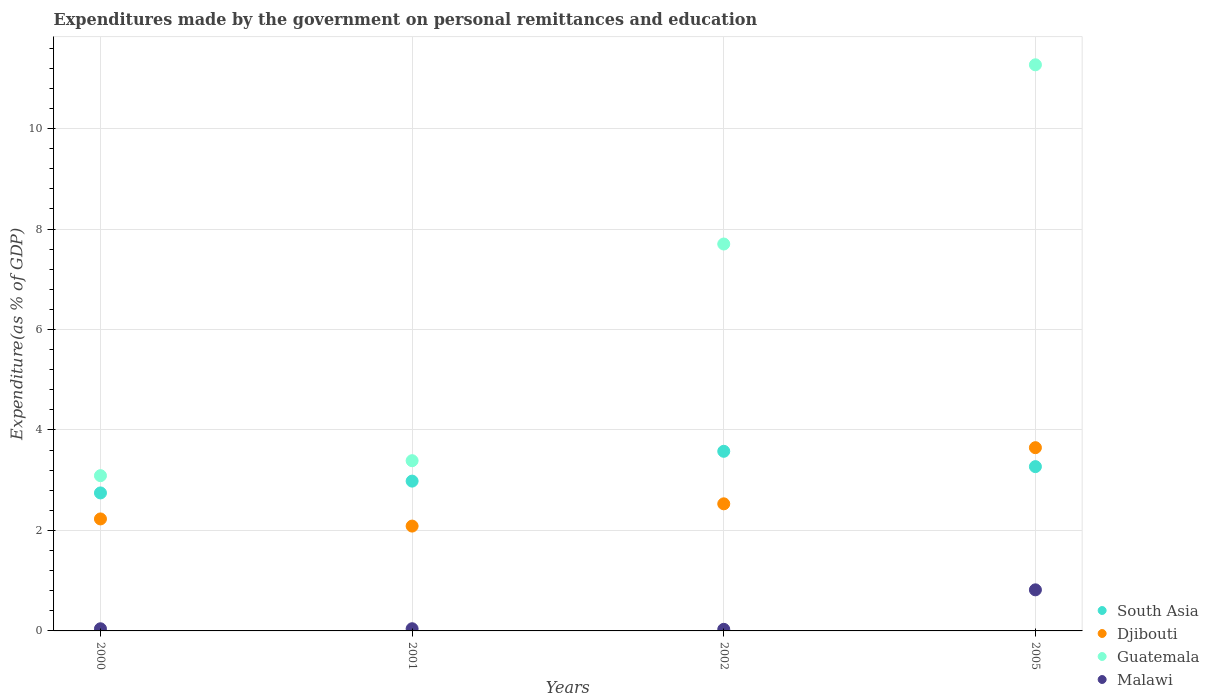Is the number of dotlines equal to the number of legend labels?
Your answer should be very brief. Yes. What is the expenditures made by the government on personal remittances and education in South Asia in 2000?
Your answer should be compact. 2.75. Across all years, what is the maximum expenditures made by the government on personal remittances and education in Malawi?
Keep it short and to the point. 0.82. Across all years, what is the minimum expenditures made by the government on personal remittances and education in Djibouti?
Your response must be concise. 2.09. In which year was the expenditures made by the government on personal remittances and education in South Asia maximum?
Your answer should be very brief. 2002. What is the total expenditures made by the government on personal remittances and education in Guatemala in the graph?
Give a very brief answer. 25.45. What is the difference between the expenditures made by the government on personal remittances and education in Djibouti in 2001 and that in 2005?
Offer a very short reply. -1.56. What is the difference between the expenditures made by the government on personal remittances and education in Guatemala in 2000 and the expenditures made by the government on personal remittances and education in Malawi in 2005?
Your answer should be compact. 2.27. What is the average expenditures made by the government on personal remittances and education in Guatemala per year?
Ensure brevity in your answer.  6.36. In the year 2001, what is the difference between the expenditures made by the government on personal remittances and education in South Asia and expenditures made by the government on personal remittances and education in Malawi?
Your answer should be very brief. 2.94. In how many years, is the expenditures made by the government on personal remittances and education in Guatemala greater than 3.2 %?
Keep it short and to the point. 3. What is the ratio of the expenditures made by the government on personal remittances and education in South Asia in 2000 to that in 2001?
Make the answer very short. 0.92. What is the difference between the highest and the second highest expenditures made by the government on personal remittances and education in Guatemala?
Offer a terse response. 3.57. What is the difference between the highest and the lowest expenditures made by the government on personal remittances and education in South Asia?
Your answer should be compact. 0.83. In how many years, is the expenditures made by the government on personal remittances and education in South Asia greater than the average expenditures made by the government on personal remittances and education in South Asia taken over all years?
Provide a short and direct response. 2. Is it the case that in every year, the sum of the expenditures made by the government on personal remittances and education in Djibouti and expenditures made by the government on personal remittances and education in Malawi  is greater than the sum of expenditures made by the government on personal remittances and education in Guatemala and expenditures made by the government on personal remittances and education in South Asia?
Provide a short and direct response. Yes. Is it the case that in every year, the sum of the expenditures made by the government on personal remittances and education in Djibouti and expenditures made by the government on personal remittances and education in Guatemala  is greater than the expenditures made by the government on personal remittances and education in South Asia?
Provide a succinct answer. Yes. How many years are there in the graph?
Keep it short and to the point. 4. Where does the legend appear in the graph?
Your response must be concise. Bottom right. What is the title of the graph?
Give a very brief answer. Expenditures made by the government on personal remittances and education. Does "Georgia" appear as one of the legend labels in the graph?
Your answer should be compact. No. What is the label or title of the Y-axis?
Make the answer very short. Expenditure(as % of GDP). What is the Expenditure(as % of GDP) in South Asia in 2000?
Offer a terse response. 2.75. What is the Expenditure(as % of GDP) of Djibouti in 2000?
Your response must be concise. 2.23. What is the Expenditure(as % of GDP) in Guatemala in 2000?
Your answer should be compact. 3.09. What is the Expenditure(as % of GDP) of Malawi in 2000?
Provide a short and direct response. 0.04. What is the Expenditure(as % of GDP) in South Asia in 2001?
Offer a terse response. 2.98. What is the Expenditure(as % of GDP) in Djibouti in 2001?
Make the answer very short. 2.09. What is the Expenditure(as % of GDP) of Guatemala in 2001?
Offer a terse response. 3.39. What is the Expenditure(as % of GDP) in Malawi in 2001?
Offer a very short reply. 0.04. What is the Expenditure(as % of GDP) in South Asia in 2002?
Offer a terse response. 3.58. What is the Expenditure(as % of GDP) in Djibouti in 2002?
Ensure brevity in your answer.  2.53. What is the Expenditure(as % of GDP) in Guatemala in 2002?
Provide a succinct answer. 7.7. What is the Expenditure(as % of GDP) in Malawi in 2002?
Give a very brief answer. 0.03. What is the Expenditure(as % of GDP) of South Asia in 2005?
Provide a short and direct response. 3.27. What is the Expenditure(as % of GDP) in Djibouti in 2005?
Ensure brevity in your answer.  3.65. What is the Expenditure(as % of GDP) in Guatemala in 2005?
Provide a short and direct response. 11.27. What is the Expenditure(as % of GDP) in Malawi in 2005?
Provide a short and direct response. 0.82. Across all years, what is the maximum Expenditure(as % of GDP) in South Asia?
Ensure brevity in your answer.  3.58. Across all years, what is the maximum Expenditure(as % of GDP) in Djibouti?
Your answer should be compact. 3.65. Across all years, what is the maximum Expenditure(as % of GDP) in Guatemala?
Your answer should be very brief. 11.27. Across all years, what is the maximum Expenditure(as % of GDP) in Malawi?
Your response must be concise. 0.82. Across all years, what is the minimum Expenditure(as % of GDP) in South Asia?
Keep it short and to the point. 2.75. Across all years, what is the minimum Expenditure(as % of GDP) of Djibouti?
Offer a terse response. 2.09. Across all years, what is the minimum Expenditure(as % of GDP) of Guatemala?
Your answer should be very brief. 3.09. Across all years, what is the minimum Expenditure(as % of GDP) in Malawi?
Make the answer very short. 0.03. What is the total Expenditure(as % of GDP) in South Asia in the graph?
Give a very brief answer. 12.58. What is the total Expenditure(as % of GDP) of Djibouti in the graph?
Ensure brevity in your answer.  10.49. What is the total Expenditure(as % of GDP) in Guatemala in the graph?
Keep it short and to the point. 25.45. What is the total Expenditure(as % of GDP) in Malawi in the graph?
Your answer should be compact. 0.94. What is the difference between the Expenditure(as % of GDP) in South Asia in 2000 and that in 2001?
Ensure brevity in your answer.  -0.24. What is the difference between the Expenditure(as % of GDP) in Djibouti in 2000 and that in 2001?
Your answer should be very brief. 0.14. What is the difference between the Expenditure(as % of GDP) in Guatemala in 2000 and that in 2001?
Keep it short and to the point. -0.3. What is the difference between the Expenditure(as % of GDP) in Malawi in 2000 and that in 2001?
Ensure brevity in your answer.  -0. What is the difference between the Expenditure(as % of GDP) of South Asia in 2000 and that in 2002?
Give a very brief answer. -0.83. What is the difference between the Expenditure(as % of GDP) in Djibouti in 2000 and that in 2002?
Offer a terse response. -0.3. What is the difference between the Expenditure(as % of GDP) in Guatemala in 2000 and that in 2002?
Give a very brief answer. -4.61. What is the difference between the Expenditure(as % of GDP) of Malawi in 2000 and that in 2002?
Make the answer very short. 0.01. What is the difference between the Expenditure(as % of GDP) of South Asia in 2000 and that in 2005?
Offer a very short reply. -0.52. What is the difference between the Expenditure(as % of GDP) of Djibouti in 2000 and that in 2005?
Ensure brevity in your answer.  -1.42. What is the difference between the Expenditure(as % of GDP) of Guatemala in 2000 and that in 2005?
Provide a short and direct response. -8.18. What is the difference between the Expenditure(as % of GDP) in Malawi in 2000 and that in 2005?
Offer a very short reply. -0.78. What is the difference between the Expenditure(as % of GDP) of South Asia in 2001 and that in 2002?
Make the answer very short. -0.59. What is the difference between the Expenditure(as % of GDP) of Djibouti in 2001 and that in 2002?
Keep it short and to the point. -0.44. What is the difference between the Expenditure(as % of GDP) of Guatemala in 2001 and that in 2002?
Provide a short and direct response. -4.31. What is the difference between the Expenditure(as % of GDP) of Malawi in 2001 and that in 2002?
Your answer should be very brief. 0.01. What is the difference between the Expenditure(as % of GDP) in South Asia in 2001 and that in 2005?
Provide a short and direct response. -0.29. What is the difference between the Expenditure(as % of GDP) in Djibouti in 2001 and that in 2005?
Make the answer very short. -1.56. What is the difference between the Expenditure(as % of GDP) in Guatemala in 2001 and that in 2005?
Provide a succinct answer. -7.88. What is the difference between the Expenditure(as % of GDP) in Malawi in 2001 and that in 2005?
Ensure brevity in your answer.  -0.77. What is the difference between the Expenditure(as % of GDP) of South Asia in 2002 and that in 2005?
Your answer should be compact. 0.3. What is the difference between the Expenditure(as % of GDP) in Djibouti in 2002 and that in 2005?
Ensure brevity in your answer.  -1.12. What is the difference between the Expenditure(as % of GDP) of Guatemala in 2002 and that in 2005?
Offer a terse response. -3.57. What is the difference between the Expenditure(as % of GDP) in Malawi in 2002 and that in 2005?
Provide a short and direct response. -0.79. What is the difference between the Expenditure(as % of GDP) of South Asia in 2000 and the Expenditure(as % of GDP) of Djibouti in 2001?
Your answer should be compact. 0.66. What is the difference between the Expenditure(as % of GDP) of South Asia in 2000 and the Expenditure(as % of GDP) of Guatemala in 2001?
Give a very brief answer. -0.64. What is the difference between the Expenditure(as % of GDP) of South Asia in 2000 and the Expenditure(as % of GDP) of Malawi in 2001?
Give a very brief answer. 2.7. What is the difference between the Expenditure(as % of GDP) of Djibouti in 2000 and the Expenditure(as % of GDP) of Guatemala in 2001?
Provide a succinct answer. -1.16. What is the difference between the Expenditure(as % of GDP) of Djibouti in 2000 and the Expenditure(as % of GDP) of Malawi in 2001?
Give a very brief answer. 2.19. What is the difference between the Expenditure(as % of GDP) in Guatemala in 2000 and the Expenditure(as % of GDP) in Malawi in 2001?
Offer a terse response. 3.05. What is the difference between the Expenditure(as % of GDP) of South Asia in 2000 and the Expenditure(as % of GDP) of Djibouti in 2002?
Make the answer very short. 0.22. What is the difference between the Expenditure(as % of GDP) of South Asia in 2000 and the Expenditure(as % of GDP) of Guatemala in 2002?
Provide a succinct answer. -4.96. What is the difference between the Expenditure(as % of GDP) in South Asia in 2000 and the Expenditure(as % of GDP) in Malawi in 2002?
Make the answer very short. 2.72. What is the difference between the Expenditure(as % of GDP) in Djibouti in 2000 and the Expenditure(as % of GDP) in Guatemala in 2002?
Give a very brief answer. -5.47. What is the difference between the Expenditure(as % of GDP) of Djibouti in 2000 and the Expenditure(as % of GDP) of Malawi in 2002?
Offer a very short reply. 2.2. What is the difference between the Expenditure(as % of GDP) of Guatemala in 2000 and the Expenditure(as % of GDP) of Malawi in 2002?
Offer a terse response. 3.06. What is the difference between the Expenditure(as % of GDP) in South Asia in 2000 and the Expenditure(as % of GDP) in Djibouti in 2005?
Offer a very short reply. -0.9. What is the difference between the Expenditure(as % of GDP) of South Asia in 2000 and the Expenditure(as % of GDP) of Guatemala in 2005?
Your response must be concise. -8.52. What is the difference between the Expenditure(as % of GDP) of South Asia in 2000 and the Expenditure(as % of GDP) of Malawi in 2005?
Make the answer very short. 1.93. What is the difference between the Expenditure(as % of GDP) in Djibouti in 2000 and the Expenditure(as % of GDP) in Guatemala in 2005?
Offer a terse response. -9.04. What is the difference between the Expenditure(as % of GDP) in Djibouti in 2000 and the Expenditure(as % of GDP) in Malawi in 2005?
Give a very brief answer. 1.41. What is the difference between the Expenditure(as % of GDP) in Guatemala in 2000 and the Expenditure(as % of GDP) in Malawi in 2005?
Ensure brevity in your answer.  2.27. What is the difference between the Expenditure(as % of GDP) in South Asia in 2001 and the Expenditure(as % of GDP) in Djibouti in 2002?
Offer a very short reply. 0.45. What is the difference between the Expenditure(as % of GDP) in South Asia in 2001 and the Expenditure(as % of GDP) in Guatemala in 2002?
Keep it short and to the point. -4.72. What is the difference between the Expenditure(as % of GDP) in South Asia in 2001 and the Expenditure(as % of GDP) in Malawi in 2002?
Your response must be concise. 2.95. What is the difference between the Expenditure(as % of GDP) in Djibouti in 2001 and the Expenditure(as % of GDP) in Guatemala in 2002?
Ensure brevity in your answer.  -5.62. What is the difference between the Expenditure(as % of GDP) of Djibouti in 2001 and the Expenditure(as % of GDP) of Malawi in 2002?
Make the answer very short. 2.06. What is the difference between the Expenditure(as % of GDP) of Guatemala in 2001 and the Expenditure(as % of GDP) of Malawi in 2002?
Your answer should be very brief. 3.36. What is the difference between the Expenditure(as % of GDP) in South Asia in 2001 and the Expenditure(as % of GDP) in Djibouti in 2005?
Offer a terse response. -0.67. What is the difference between the Expenditure(as % of GDP) of South Asia in 2001 and the Expenditure(as % of GDP) of Guatemala in 2005?
Provide a short and direct response. -8.29. What is the difference between the Expenditure(as % of GDP) in South Asia in 2001 and the Expenditure(as % of GDP) in Malawi in 2005?
Provide a short and direct response. 2.16. What is the difference between the Expenditure(as % of GDP) in Djibouti in 2001 and the Expenditure(as % of GDP) in Guatemala in 2005?
Your answer should be compact. -9.18. What is the difference between the Expenditure(as % of GDP) of Djibouti in 2001 and the Expenditure(as % of GDP) of Malawi in 2005?
Provide a succinct answer. 1.27. What is the difference between the Expenditure(as % of GDP) in Guatemala in 2001 and the Expenditure(as % of GDP) in Malawi in 2005?
Provide a succinct answer. 2.57. What is the difference between the Expenditure(as % of GDP) of South Asia in 2002 and the Expenditure(as % of GDP) of Djibouti in 2005?
Offer a very short reply. -0.07. What is the difference between the Expenditure(as % of GDP) in South Asia in 2002 and the Expenditure(as % of GDP) in Guatemala in 2005?
Keep it short and to the point. -7.69. What is the difference between the Expenditure(as % of GDP) in South Asia in 2002 and the Expenditure(as % of GDP) in Malawi in 2005?
Your answer should be compact. 2.76. What is the difference between the Expenditure(as % of GDP) of Djibouti in 2002 and the Expenditure(as % of GDP) of Guatemala in 2005?
Your answer should be compact. -8.74. What is the difference between the Expenditure(as % of GDP) of Djibouti in 2002 and the Expenditure(as % of GDP) of Malawi in 2005?
Your response must be concise. 1.71. What is the difference between the Expenditure(as % of GDP) in Guatemala in 2002 and the Expenditure(as % of GDP) in Malawi in 2005?
Offer a very short reply. 6.88. What is the average Expenditure(as % of GDP) in South Asia per year?
Provide a succinct answer. 3.14. What is the average Expenditure(as % of GDP) in Djibouti per year?
Your answer should be very brief. 2.62. What is the average Expenditure(as % of GDP) in Guatemala per year?
Your answer should be compact. 6.36. What is the average Expenditure(as % of GDP) of Malawi per year?
Offer a terse response. 0.23. In the year 2000, what is the difference between the Expenditure(as % of GDP) in South Asia and Expenditure(as % of GDP) in Djibouti?
Your answer should be very brief. 0.52. In the year 2000, what is the difference between the Expenditure(as % of GDP) of South Asia and Expenditure(as % of GDP) of Guatemala?
Your answer should be compact. -0.34. In the year 2000, what is the difference between the Expenditure(as % of GDP) in South Asia and Expenditure(as % of GDP) in Malawi?
Your response must be concise. 2.7. In the year 2000, what is the difference between the Expenditure(as % of GDP) in Djibouti and Expenditure(as % of GDP) in Guatemala?
Your answer should be very brief. -0.86. In the year 2000, what is the difference between the Expenditure(as % of GDP) of Djibouti and Expenditure(as % of GDP) of Malawi?
Your answer should be very brief. 2.19. In the year 2000, what is the difference between the Expenditure(as % of GDP) of Guatemala and Expenditure(as % of GDP) of Malawi?
Your response must be concise. 3.05. In the year 2001, what is the difference between the Expenditure(as % of GDP) in South Asia and Expenditure(as % of GDP) in Djibouti?
Your answer should be compact. 0.9. In the year 2001, what is the difference between the Expenditure(as % of GDP) in South Asia and Expenditure(as % of GDP) in Guatemala?
Give a very brief answer. -0.41. In the year 2001, what is the difference between the Expenditure(as % of GDP) of South Asia and Expenditure(as % of GDP) of Malawi?
Your answer should be compact. 2.94. In the year 2001, what is the difference between the Expenditure(as % of GDP) of Djibouti and Expenditure(as % of GDP) of Guatemala?
Provide a short and direct response. -1.3. In the year 2001, what is the difference between the Expenditure(as % of GDP) in Djibouti and Expenditure(as % of GDP) in Malawi?
Provide a short and direct response. 2.04. In the year 2001, what is the difference between the Expenditure(as % of GDP) in Guatemala and Expenditure(as % of GDP) in Malawi?
Make the answer very short. 3.35. In the year 2002, what is the difference between the Expenditure(as % of GDP) of South Asia and Expenditure(as % of GDP) of Djibouti?
Offer a very short reply. 1.05. In the year 2002, what is the difference between the Expenditure(as % of GDP) in South Asia and Expenditure(as % of GDP) in Guatemala?
Keep it short and to the point. -4.13. In the year 2002, what is the difference between the Expenditure(as % of GDP) of South Asia and Expenditure(as % of GDP) of Malawi?
Offer a very short reply. 3.54. In the year 2002, what is the difference between the Expenditure(as % of GDP) of Djibouti and Expenditure(as % of GDP) of Guatemala?
Your answer should be very brief. -5.17. In the year 2002, what is the difference between the Expenditure(as % of GDP) in Djibouti and Expenditure(as % of GDP) in Malawi?
Your response must be concise. 2.5. In the year 2002, what is the difference between the Expenditure(as % of GDP) of Guatemala and Expenditure(as % of GDP) of Malawi?
Keep it short and to the point. 7.67. In the year 2005, what is the difference between the Expenditure(as % of GDP) of South Asia and Expenditure(as % of GDP) of Djibouti?
Give a very brief answer. -0.38. In the year 2005, what is the difference between the Expenditure(as % of GDP) of South Asia and Expenditure(as % of GDP) of Guatemala?
Offer a very short reply. -8. In the year 2005, what is the difference between the Expenditure(as % of GDP) in South Asia and Expenditure(as % of GDP) in Malawi?
Offer a very short reply. 2.45. In the year 2005, what is the difference between the Expenditure(as % of GDP) of Djibouti and Expenditure(as % of GDP) of Guatemala?
Offer a terse response. -7.62. In the year 2005, what is the difference between the Expenditure(as % of GDP) of Djibouti and Expenditure(as % of GDP) of Malawi?
Offer a terse response. 2.83. In the year 2005, what is the difference between the Expenditure(as % of GDP) of Guatemala and Expenditure(as % of GDP) of Malawi?
Provide a succinct answer. 10.45. What is the ratio of the Expenditure(as % of GDP) in South Asia in 2000 to that in 2001?
Keep it short and to the point. 0.92. What is the ratio of the Expenditure(as % of GDP) in Djibouti in 2000 to that in 2001?
Give a very brief answer. 1.07. What is the ratio of the Expenditure(as % of GDP) of Guatemala in 2000 to that in 2001?
Your answer should be very brief. 0.91. What is the ratio of the Expenditure(as % of GDP) of Malawi in 2000 to that in 2001?
Offer a terse response. 0.98. What is the ratio of the Expenditure(as % of GDP) in South Asia in 2000 to that in 2002?
Your answer should be very brief. 0.77. What is the ratio of the Expenditure(as % of GDP) in Djibouti in 2000 to that in 2002?
Your answer should be very brief. 0.88. What is the ratio of the Expenditure(as % of GDP) in Guatemala in 2000 to that in 2002?
Provide a short and direct response. 0.4. What is the ratio of the Expenditure(as % of GDP) of Malawi in 2000 to that in 2002?
Make the answer very short. 1.35. What is the ratio of the Expenditure(as % of GDP) in South Asia in 2000 to that in 2005?
Give a very brief answer. 0.84. What is the ratio of the Expenditure(as % of GDP) in Djibouti in 2000 to that in 2005?
Offer a very short reply. 0.61. What is the ratio of the Expenditure(as % of GDP) of Guatemala in 2000 to that in 2005?
Give a very brief answer. 0.27. What is the ratio of the Expenditure(as % of GDP) in Malawi in 2000 to that in 2005?
Provide a short and direct response. 0.05. What is the ratio of the Expenditure(as % of GDP) in South Asia in 2001 to that in 2002?
Ensure brevity in your answer.  0.83. What is the ratio of the Expenditure(as % of GDP) in Djibouti in 2001 to that in 2002?
Your answer should be compact. 0.82. What is the ratio of the Expenditure(as % of GDP) in Guatemala in 2001 to that in 2002?
Keep it short and to the point. 0.44. What is the ratio of the Expenditure(as % of GDP) in Malawi in 2001 to that in 2002?
Provide a succinct answer. 1.37. What is the ratio of the Expenditure(as % of GDP) of South Asia in 2001 to that in 2005?
Offer a terse response. 0.91. What is the ratio of the Expenditure(as % of GDP) of Djibouti in 2001 to that in 2005?
Give a very brief answer. 0.57. What is the ratio of the Expenditure(as % of GDP) of Guatemala in 2001 to that in 2005?
Keep it short and to the point. 0.3. What is the ratio of the Expenditure(as % of GDP) in Malawi in 2001 to that in 2005?
Provide a short and direct response. 0.05. What is the ratio of the Expenditure(as % of GDP) in South Asia in 2002 to that in 2005?
Your answer should be very brief. 1.09. What is the ratio of the Expenditure(as % of GDP) in Djibouti in 2002 to that in 2005?
Make the answer very short. 0.69. What is the ratio of the Expenditure(as % of GDP) of Guatemala in 2002 to that in 2005?
Provide a short and direct response. 0.68. What is the ratio of the Expenditure(as % of GDP) of Malawi in 2002 to that in 2005?
Make the answer very short. 0.04. What is the difference between the highest and the second highest Expenditure(as % of GDP) of South Asia?
Ensure brevity in your answer.  0.3. What is the difference between the highest and the second highest Expenditure(as % of GDP) in Djibouti?
Provide a short and direct response. 1.12. What is the difference between the highest and the second highest Expenditure(as % of GDP) in Guatemala?
Keep it short and to the point. 3.57. What is the difference between the highest and the second highest Expenditure(as % of GDP) in Malawi?
Your response must be concise. 0.77. What is the difference between the highest and the lowest Expenditure(as % of GDP) in South Asia?
Your response must be concise. 0.83. What is the difference between the highest and the lowest Expenditure(as % of GDP) in Djibouti?
Give a very brief answer. 1.56. What is the difference between the highest and the lowest Expenditure(as % of GDP) of Guatemala?
Provide a short and direct response. 8.18. What is the difference between the highest and the lowest Expenditure(as % of GDP) in Malawi?
Ensure brevity in your answer.  0.79. 